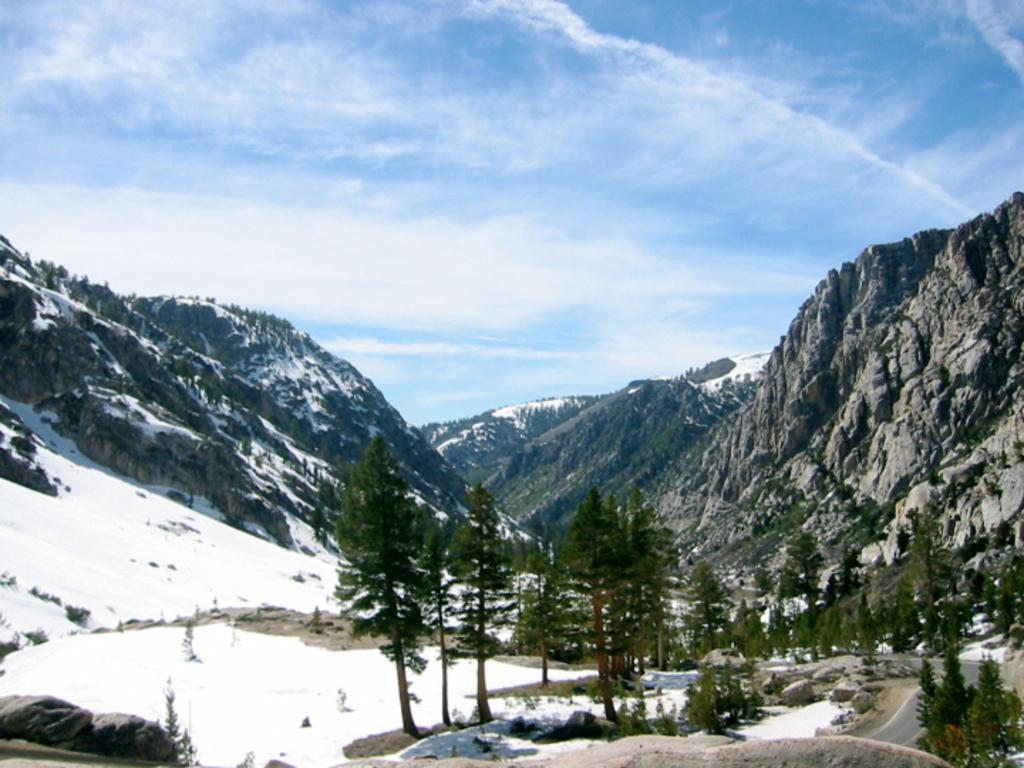What type of vegetation can be seen in the image? There are trees in the image. What is covering the ground on the left side of the image? There is snow on the ground on the left side of the image. What can be seen in the distance in the image? There are hills in the background of the image. What is visible in the sky in the image? The sky is visible in the background of the image. Can you tell me how many chess pieces are on the ground in the image? There are no chess pieces present in the image; it features trees, snow, hills, and the sky. Is the mother visible in the image? There is no mention of a mother or any people in the image, only trees, snow, hills, and the sky. 